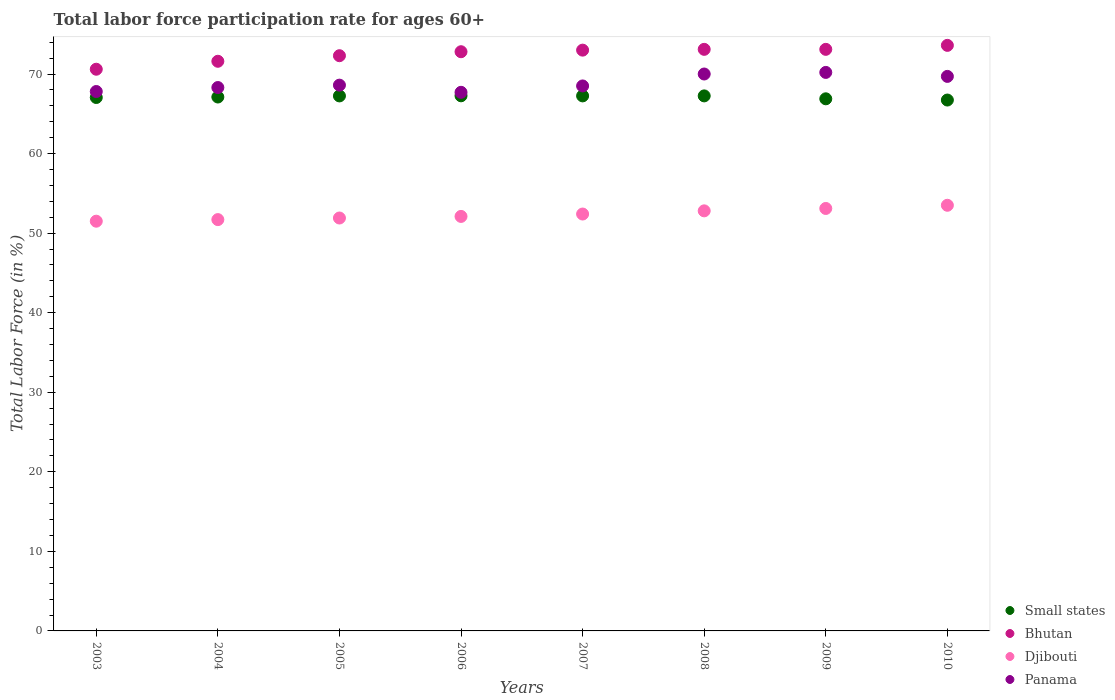Is the number of dotlines equal to the number of legend labels?
Offer a terse response. Yes. What is the labor force participation rate in Djibouti in 2008?
Your answer should be compact. 52.8. Across all years, what is the maximum labor force participation rate in Bhutan?
Offer a very short reply. 73.6. Across all years, what is the minimum labor force participation rate in Djibouti?
Make the answer very short. 51.5. What is the total labor force participation rate in Panama in the graph?
Your answer should be very brief. 550.8. What is the difference between the labor force participation rate in Djibouti in 2004 and that in 2010?
Your response must be concise. -1.8. What is the difference between the labor force participation rate in Djibouti in 2004 and the labor force participation rate in Panama in 2009?
Your answer should be compact. -18.5. What is the average labor force participation rate in Panama per year?
Give a very brief answer. 68.85. In the year 2008, what is the difference between the labor force participation rate in Panama and labor force participation rate in Djibouti?
Your answer should be compact. 17.2. What is the ratio of the labor force participation rate in Djibouti in 2009 to that in 2010?
Your answer should be compact. 0.99. Is the difference between the labor force participation rate in Panama in 2006 and 2007 greater than the difference between the labor force participation rate in Djibouti in 2006 and 2007?
Give a very brief answer. No. What is the difference between the highest and the second highest labor force participation rate in Djibouti?
Your response must be concise. 0.4. What is the difference between the highest and the lowest labor force participation rate in Bhutan?
Your answer should be compact. 3. Is it the case that in every year, the sum of the labor force participation rate in Bhutan and labor force participation rate in Panama  is greater than the labor force participation rate in Djibouti?
Offer a terse response. Yes. Is the labor force participation rate in Djibouti strictly less than the labor force participation rate in Bhutan over the years?
Your answer should be compact. Yes. How many dotlines are there?
Your answer should be very brief. 4. How many years are there in the graph?
Your answer should be compact. 8. Are the values on the major ticks of Y-axis written in scientific E-notation?
Ensure brevity in your answer.  No. Does the graph contain any zero values?
Your answer should be very brief. No. How many legend labels are there?
Provide a succinct answer. 4. How are the legend labels stacked?
Provide a succinct answer. Vertical. What is the title of the graph?
Provide a short and direct response. Total labor force participation rate for ages 60+. Does "Cuba" appear as one of the legend labels in the graph?
Provide a succinct answer. No. What is the Total Labor Force (in %) of Small states in 2003?
Make the answer very short. 67.05. What is the Total Labor Force (in %) in Bhutan in 2003?
Give a very brief answer. 70.6. What is the Total Labor Force (in %) in Djibouti in 2003?
Provide a succinct answer. 51.5. What is the Total Labor Force (in %) in Panama in 2003?
Keep it short and to the point. 67.8. What is the Total Labor Force (in %) of Small states in 2004?
Ensure brevity in your answer.  67.11. What is the Total Labor Force (in %) in Bhutan in 2004?
Give a very brief answer. 71.6. What is the Total Labor Force (in %) of Djibouti in 2004?
Your answer should be very brief. 51.7. What is the Total Labor Force (in %) of Panama in 2004?
Offer a very short reply. 68.3. What is the Total Labor Force (in %) in Small states in 2005?
Provide a short and direct response. 67.25. What is the Total Labor Force (in %) of Bhutan in 2005?
Give a very brief answer. 72.3. What is the Total Labor Force (in %) of Djibouti in 2005?
Offer a terse response. 51.9. What is the Total Labor Force (in %) in Panama in 2005?
Offer a very short reply. 68.6. What is the Total Labor Force (in %) of Small states in 2006?
Your response must be concise. 67.26. What is the Total Labor Force (in %) of Bhutan in 2006?
Offer a terse response. 72.8. What is the Total Labor Force (in %) of Djibouti in 2006?
Your answer should be compact. 52.1. What is the Total Labor Force (in %) in Panama in 2006?
Keep it short and to the point. 67.7. What is the Total Labor Force (in %) in Small states in 2007?
Provide a succinct answer. 67.25. What is the Total Labor Force (in %) in Bhutan in 2007?
Ensure brevity in your answer.  73. What is the Total Labor Force (in %) in Djibouti in 2007?
Ensure brevity in your answer.  52.4. What is the Total Labor Force (in %) of Panama in 2007?
Offer a terse response. 68.5. What is the Total Labor Force (in %) of Small states in 2008?
Offer a very short reply. 67.25. What is the Total Labor Force (in %) of Bhutan in 2008?
Ensure brevity in your answer.  73.1. What is the Total Labor Force (in %) in Djibouti in 2008?
Ensure brevity in your answer.  52.8. What is the Total Labor Force (in %) in Small states in 2009?
Offer a terse response. 66.88. What is the Total Labor Force (in %) of Bhutan in 2009?
Make the answer very short. 73.1. What is the Total Labor Force (in %) in Djibouti in 2009?
Keep it short and to the point. 53.1. What is the Total Labor Force (in %) of Panama in 2009?
Your response must be concise. 70.2. What is the Total Labor Force (in %) of Small states in 2010?
Your response must be concise. 66.73. What is the Total Labor Force (in %) in Bhutan in 2010?
Your answer should be very brief. 73.6. What is the Total Labor Force (in %) in Djibouti in 2010?
Your response must be concise. 53.5. What is the Total Labor Force (in %) of Panama in 2010?
Offer a very short reply. 69.7. Across all years, what is the maximum Total Labor Force (in %) of Small states?
Give a very brief answer. 67.26. Across all years, what is the maximum Total Labor Force (in %) in Bhutan?
Make the answer very short. 73.6. Across all years, what is the maximum Total Labor Force (in %) in Djibouti?
Make the answer very short. 53.5. Across all years, what is the maximum Total Labor Force (in %) of Panama?
Give a very brief answer. 70.2. Across all years, what is the minimum Total Labor Force (in %) in Small states?
Offer a terse response. 66.73. Across all years, what is the minimum Total Labor Force (in %) in Bhutan?
Provide a short and direct response. 70.6. Across all years, what is the minimum Total Labor Force (in %) in Djibouti?
Provide a short and direct response. 51.5. Across all years, what is the minimum Total Labor Force (in %) of Panama?
Make the answer very short. 67.7. What is the total Total Labor Force (in %) of Small states in the graph?
Offer a very short reply. 536.77. What is the total Total Labor Force (in %) of Bhutan in the graph?
Provide a short and direct response. 580.1. What is the total Total Labor Force (in %) in Djibouti in the graph?
Give a very brief answer. 419. What is the total Total Labor Force (in %) in Panama in the graph?
Your answer should be very brief. 550.8. What is the difference between the Total Labor Force (in %) in Small states in 2003 and that in 2004?
Offer a very short reply. -0.06. What is the difference between the Total Labor Force (in %) of Djibouti in 2003 and that in 2004?
Your answer should be very brief. -0.2. What is the difference between the Total Labor Force (in %) in Panama in 2003 and that in 2004?
Ensure brevity in your answer.  -0.5. What is the difference between the Total Labor Force (in %) in Small states in 2003 and that in 2005?
Keep it short and to the point. -0.2. What is the difference between the Total Labor Force (in %) in Panama in 2003 and that in 2005?
Your answer should be very brief. -0.8. What is the difference between the Total Labor Force (in %) in Small states in 2003 and that in 2006?
Keep it short and to the point. -0.21. What is the difference between the Total Labor Force (in %) of Bhutan in 2003 and that in 2006?
Provide a succinct answer. -2.2. What is the difference between the Total Labor Force (in %) of Panama in 2003 and that in 2006?
Provide a short and direct response. 0.1. What is the difference between the Total Labor Force (in %) of Small states in 2003 and that in 2007?
Provide a short and direct response. -0.2. What is the difference between the Total Labor Force (in %) of Bhutan in 2003 and that in 2007?
Provide a succinct answer. -2.4. What is the difference between the Total Labor Force (in %) in Panama in 2003 and that in 2007?
Your response must be concise. -0.7. What is the difference between the Total Labor Force (in %) in Small states in 2003 and that in 2008?
Make the answer very short. -0.2. What is the difference between the Total Labor Force (in %) in Bhutan in 2003 and that in 2008?
Provide a short and direct response. -2.5. What is the difference between the Total Labor Force (in %) in Djibouti in 2003 and that in 2008?
Provide a short and direct response. -1.3. What is the difference between the Total Labor Force (in %) in Panama in 2003 and that in 2008?
Your answer should be compact. -2.2. What is the difference between the Total Labor Force (in %) in Small states in 2003 and that in 2009?
Your answer should be very brief. 0.17. What is the difference between the Total Labor Force (in %) of Bhutan in 2003 and that in 2009?
Your answer should be compact. -2.5. What is the difference between the Total Labor Force (in %) of Djibouti in 2003 and that in 2009?
Offer a very short reply. -1.6. What is the difference between the Total Labor Force (in %) of Small states in 2003 and that in 2010?
Provide a short and direct response. 0.32. What is the difference between the Total Labor Force (in %) of Small states in 2004 and that in 2005?
Make the answer very short. -0.14. What is the difference between the Total Labor Force (in %) in Bhutan in 2004 and that in 2005?
Provide a succinct answer. -0.7. What is the difference between the Total Labor Force (in %) in Small states in 2004 and that in 2006?
Provide a short and direct response. -0.15. What is the difference between the Total Labor Force (in %) in Djibouti in 2004 and that in 2006?
Your response must be concise. -0.4. What is the difference between the Total Labor Force (in %) in Small states in 2004 and that in 2007?
Your answer should be compact. -0.14. What is the difference between the Total Labor Force (in %) of Bhutan in 2004 and that in 2007?
Make the answer very short. -1.4. What is the difference between the Total Labor Force (in %) of Panama in 2004 and that in 2007?
Keep it short and to the point. -0.2. What is the difference between the Total Labor Force (in %) in Small states in 2004 and that in 2008?
Offer a terse response. -0.14. What is the difference between the Total Labor Force (in %) of Bhutan in 2004 and that in 2008?
Ensure brevity in your answer.  -1.5. What is the difference between the Total Labor Force (in %) in Panama in 2004 and that in 2008?
Offer a terse response. -1.7. What is the difference between the Total Labor Force (in %) in Small states in 2004 and that in 2009?
Ensure brevity in your answer.  0.22. What is the difference between the Total Labor Force (in %) of Small states in 2004 and that in 2010?
Keep it short and to the point. 0.38. What is the difference between the Total Labor Force (in %) of Small states in 2005 and that in 2006?
Offer a very short reply. -0.01. What is the difference between the Total Labor Force (in %) of Djibouti in 2005 and that in 2006?
Your answer should be compact. -0.2. What is the difference between the Total Labor Force (in %) of Panama in 2005 and that in 2006?
Make the answer very short. 0.9. What is the difference between the Total Labor Force (in %) in Small states in 2005 and that in 2007?
Provide a succinct answer. -0. What is the difference between the Total Labor Force (in %) of Bhutan in 2005 and that in 2007?
Your response must be concise. -0.7. What is the difference between the Total Labor Force (in %) of Panama in 2005 and that in 2007?
Your answer should be compact. 0.1. What is the difference between the Total Labor Force (in %) in Small states in 2005 and that in 2008?
Offer a terse response. -0. What is the difference between the Total Labor Force (in %) in Djibouti in 2005 and that in 2008?
Your answer should be very brief. -0.9. What is the difference between the Total Labor Force (in %) of Panama in 2005 and that in 2008?
Offer a very short reply. -1.4. What is the difference between the Total Labor Force (in %) in Small states in 2005 and that in 2009?
Provide a succinct answer. 0.36. What is the difference between the Total Labor Force (in %) of Djibouti in 2005 and that in 2009?
Make the answer very short. -1.2. What is the difference between the Total Labor Force (in %) in Panama in 2005 and that in 2009?
Ensure brevity in your answer.  -1.6. What is the difference between the Total Labor Force (in %) in Small states in 2005 and that in 2010?
Your answer should be very brief. 0.52. What is the difference between the Total Labor Force (in %) in Bhutan in 2005 and that in 2010?
Your answer should be compact. -1.3. What is the difference between the Total Labor Force (in %) in Djibouti in 2005 and that in 2010?
Your response must be concise. -1.6. What is the difference between the Total Labor Force (in %) of Panama in 2005 and that in 2010?
Provide a short and direct response. -1.1. What is the difference between the Total Labor Force (in %) of Small states in 2006 and that in 2007?
Offer a terse response. 0.01. What is the difference between the Total Labor Force (in %) in Bhutan in 2006 and that in 2007?
Your response must be concise. -0.2. What is the difference between the Total Labor Force (in %) of Djibouti in 2006 and that in 2007?
Your answer should be very brief. -0.3. What is the difference between the Total Labor Force (in %) in Small states in 2006 and that in 2008?
Offer a terse response. 0.01. What is the difference between the Total Labor Force (in %) in Bhutan in 2006 and that in 2008?
Ensure brevity in your answer.  -0.3. What is the difference between the Total Labor Force (in %) of Djibouti in 2006 and that in 2008?
Provide a short and direct response. -0.7. What is the difference between the Total Labor Force (in %) of Panama in 2006 and that in 2008?
Ensure brevity in your answer.  -2.3. What is the difference between the Total Labor Force (in %) in Small states in 2006 and that in 2009?
Your response must be concise. 0.38. What is the difference between the Total Labor Force (in %) in Bhutan in 2006 and that in 2009?
Provide a short and direct response. -0.3. What is the difference between the Total Labor Force (in %) of Djibouti in 2006 and that in 2009?
Your answer should be very brief. -1. What is the difference between the Total Labor Force (in %) of Panama in 2006 and that in 2009?
Your response must be concise. -2.5. What is the difference between the Total Labor Force (in %) of Small states in 2006 and that in 2010?
Ensure brevity in your answer.  0.53. What is the difference between the Total Labor Force (in %) of Djibouti in 2006 and that in 2010?
Make the answer very short. -1.4. What is the difference between the Total Labor Force (in %) of Panama in 2006 and that in 2010?
Provide a short and direct response. -2. What is the difference between the Total Labor Force (in %) in Bhutan in 2007 and that in 2008?
Keep it short and to the point. -0.1. What is the difference between the Total Labor Force (in %) of Djibouti in 2007 and that in 2008?
Your response must be concise. -0.4. What is the difference between the Total Labor Force (in %) of Panama in 2007 and that in 2008?
Offer a very short reply. -1.5. What is the difference between the Total Labor Force (in %) of Small states in 2007 and that in 2009?
Offer a terse response. 0.37. What is the difference between the Total Labor Force (in %) in Bhutan in 2007 and that in 2009?
Your answer should be very brief. -0.1. What is the difference between the Total Labor Force (in %) in Djibouti in 2007 and that in 2009?
Your answer should be very brief. -0.7. What is the difference between the Total Labor Force (in %) of Small states in 2007 and that in 2010?
Your answer should be very brief. 0.52. What is the difference between the Total Labor Force (in %) of Bhutan in 2007 and that in 2010?
Your response must be concise. -0.6. What is the difference between the Total Labor Force (in %) in Small states in 2008 and that in 2009?
Provide a short and direct response. 0.37. What is the difference between the Total Labor Force (in %) in Small states in 2008 and that in 2010?
Keep it short and to the point. 0.52. What is the difference between the Total Labor Force (in %) in Bhutan in 2008 and that in 2010?
Offer a terse response. -0.5. What is the difference between the Total Labor Force (in %) in Djibouti in 2008 and that in 2010?
Keep it short and to the point. -0.7. What is the difference between the Total Labor Force (in %) of Small states in 2009 and that in 2010?
Offer a terse response. 0.15. What is the difference between the Total Labor Force (in %) in Djibouti in 2009 and that in 2010?
Provide a short and direct response. -0.4. What is the difference between the Total Labor Force (in %) of Small states in 2003 and the Total Labor Force (in %) of Bhutan in 2004?
Keep it short and to the point. -4.55. What is the difference between the Total Labor Force (in %) of Small states in 2003 and the Total Labor Force (in %) of Djibouti in 2004?
Provide a short and direct response. 15.35. What is the difference between the Total Labor Force (in %) in Small states in 2003 and the Total Labor Force (in %) in Panama in 2004?
Offer a very short reply. -1.25. What is the difference between the Total Labor Force (in %) in Bhutan in 2003 and the Total Labor Force (in %) in Panama in 2004?
Give a very brief answer. 2.3. What is the difference between the Total Labor Force (in %) of Djibouti in 2003 and the Total Labor Force (in %) of Panama in 2004?
Your answer should be compact. -16.8. What is the difference between the Total Labor Force (in %) of Small states in 2003 and the Total Labor Force (in %) of Bhutan in 2005?
Offer a very short reply. -5.25. What is the difference between the Total Labor Force (in %) in Small states in 2003 and the Total Labor Force (in %) in Djibouti in 2005?
Provide a short and direct response. 15.15. What is the difference between the Total Labor Force (in %) in Small states in 2003 and the Total Labor Force (in %) in Panama in 2005?
Give a very brief answer. -1.55. What is the difference between the Total Labor Force (in %) in Bhutan in 2003 and the Total Labor Force (in %) in Djibouti in 2005?
Provide a short and direct response. 18.7. What is the difference between the Total Labor Force (in %) in Djibouti in 2003 and the Total Labor Force (in %) in Panama in 2005?
Make the answer very short. -17.1. What is the difference between the Total Labor Force (in %) in Small states in 2003 and the Total Labor Force (in %) in Bhutan in 2006?
Provide a succinct answer. -5.75. What is the difference between the Total Labor Force (in %) of Small states in 2003 and the Total Labor Force (in %) of Djibouti in 2006?
Keep it short and to the point. 14.95. What is the difference between the Total Labor Force (in %) in Small states in 2003 and the Total Labor Force (in %) in Panama in 2006?
Provide a succinct answer. -0.65. What is the difference between the Total Labor Force (in %) in Djibouti in 2003 and the Total Labor Force (in %) in Panama in 2006?
Your answer should be very brief. -16.2. What is the difference between the Total Labor Force (in %) in Small states in 2003 and the Total Labor Force (in %) in Bhutan in 2007?
Offer a terse response. -5.95. What is the difference between the Total Labor Force (in %) in Small states in 2003 and the Total Labor Force (in %) in Djibouti in 2007?
Offer a very short reply. 14.65. What is the difference between the Total Labor Force (in %) in Small states in 2003 and the Total Labor Force (in %) in Panama in 2007?
Your answer should be very brief. -1.45. What is the difference between the Total Labor Force (in %) of Bhutan in 2003 and the Total Labor Force (in %) of Djibouti in 2007?
Offer a terse response. 18.2. What is the difference between the Total Labor Force (in %) of Small states in 2003 and the Total Labor Force (in %) of Bhutan in 2008?
Keep it short and to the point. -6.05. What is the difference between the Total Labor Force (in %) of Small states in 2003 and the Total Labor Force (in %) of Djibouti in 2008?
Give a very brief answer. 14.25. What is the difference between the Total Labor Force (in %) in Small states in 2003 and the Total Labor Force (in %) in Panama in 2008?
Provide a short and direct response. -2.95. What is the difference between the Total Labor Force (in %) in Bhutan in 2003 and the Total Labor Force (in %) in Djibouti in 2008?
Provide a short and direct response. 17.8. What is the difference between the Total Labor Force (in %) in Bhutan in 2003 and the Total Labor Force (in %) in Panama in 2008?
Provide a short and direct response. 0.6. What is the difference between the Total Labor Force (in %) of Djibouti in 2003 and the Total Labor Force (in %) of Panama in 2008?
Your answer should be compact. -18.5. What is the difference between the Total Labor Force (in %) of Small states in 2003 and the Total Labor Force (in %) of Bhutan in 2009?
Your answer should be very brief. -6.05. What is the difference between the Total Labor Force (in %) of Small states in 2003 and the Total Labor Force (in %) of Djibouti in 2009?
Offer a very short reply. 13.95. What is the difference between the Total Labor Force (in %) in Small states in 2003 and the Total Labor Force (in %) in Panama in 2009?
Your answer should be very brief. -3.15. What is the difference between the Total Labor Force (in %) in Bhutan in 2003 and the Total Labor Force (in %) in Djibouti in 2009?
Provide a succinct answer. 17.5. What is the difference between the Total Labor Force (in %) in Djibouti in 2003 and the Total Labor Force (in %) in Panama in 2009?
Keep it short and to the point. -18.7. What is the difference between the Total Labor Force (in %) in Small states in 2003 and the Total Labor Force (in %) in Bhutan in 2010?
Offer a very short reply. -6.55. What is the difference between the Total Labor Force (in %) in Small states in 2003 and the Total Labor Force (in %) in Djibouti in 2010?
Keep it short and to the point. 13.55. What is the difference between the Total Labor Force (in %) in Small states in 2003 and the Total Labor Force (in %) in Panama in 2010?
Make the answer very short. -2.65. What is the difference between the Total Labor Force (in %) of Bhutan in 2003 and the Total Labor Force (in %) of Djibouti in 2010?
Provide a succinct answer. 17.1. What is the difference between the Total Labor Force (in %) in Bhutan in 2003 and the Total Labor Force (in %) in Panama in 2010?
Give a very brief answer. 0.9. What is the difference between the Total Labor Force (in %) in Djibouti in 2003 and the Total Labor Force (in %) in Panama in 2010?
Make the answer very short. -18.2. What is the difference between the Total Labor Force (in %) of Small states in 2004 and the Total Labor Force (in %) of Bhutan in 2005?
Provide a succinct answer. -5.19. What is the difference between the Total Labor Force (in %) of Small states in 2004 and the Total Labor Force (in %) of Djibouti in 2005?
Provide a short and direct response. 15.21. What is the difference between the Total Labor Force (in %) in Small states in 2004 and the Total Labor Force (in %) in Panama in 2005?
Offer a very short reply. -1.49. What is the difference between the Total Labor Force (in %) in Djibouti in 2004 and the Total Labor Force (in %) in Panama in 2005?
Your response must be concise. -16.9. What is the difference between the Total Labor Force (in %) in Small states in 2004 and the Total Labor Force (in %) in Bhutan in 2006?
Keep it short and to the point. -5.69. What is the difference between the Total Labor Force (in %) of Small states in 2004 and the Total Labor Force (in %) of Djibouti in 2006?
Provide a succinct answer. 15.01. What is the difference between the Total Labor Force (in %) of Small states in 2004 and the Total Labor Force (in %) of Panama in 2006?
Provide a succinct answer. -0.59. What is the difference between the Total Labor Force (in %) in Bhutan in 2004 and the Total Labor Force (in %) in Djibouti in 2006?
Give a very brief answer. 19.5. What is the difference between the Total Labor Force (in %) in Small states in 2004 and the Total Labor Force (in %) in Bhutan in 2007?
Keep it short and to the point. -5.89. What is the difference between the Total Labor Force (in %) in Small states in 2004 and the Total Labor Force (in %) in Djibouti in 2007?
Ensure brevity in your answer.  14.71. What is the difference between the Total Labor Force (in %) in Small states in 2004 and the Total Labor Force (in %) in Panama in 2007?
Give a very brief answer. -1.39. What is the difference between the Total Labor Force (in %) of Djibouti in 2004 and the Total Labor Force (in %) of Panama in 2007?
Provide a succinct answer. -16.8. What is the difference between the Total Labor Force (in %) of Small states in 2004 and the Total Labor Force (in %) of Bhutan in 2008?
Provide a succinct answer. -5.99. What is the difference between the Total Labor Force (in %) of Small states in 2004 and the Total Labor Force (in %) of Djibouti in 2008?
Provide a succinct answer. 14.31. What is the difference between the Total Labor Force (in %) in Small states in 2004 and the Total Labor Force (in %) in Panama in 2008?
Offer a terse response. -2.89. What is the difference between the Total Labor Force (in %) in Djibouti in 2004 and the Total Labor Force (in %) in Panama in 2008?
Your response must be concise. -18.3. What is the difference between the Total Labor Force (in %) of Small states in 2004 and the Total Labor Force (in %) of Bhutan in 2009?
Offer a terse response. -5.99. What is the difference between the Total Labor Force (in %) of Small states in 2004 and the Total Labor Force (in %) of Djibouti in 2009?
Provide a short and direct response. 14.01. What is the difference between the Total Labor Force (in %) in Small states in 2004 and the Total Labor Force (in %) in Panama in 2009?
Make the answer very short. -3.09. What is the difference between the Total Labor Force (in %) of Djibouti in 2004 and the Total Labor Force (in %) of Panama in 2009?
Give a very brief answer. -18.5. What is the difference between the Total Labor Force (in %) in Small states in 2004 and the Total Labor Force (in %) in Bhutan in 2010?
Ensure brevity in your answer.  -6.49. What is the difference between the Total Labor Force (in %) in Small states in 2004 and the Total Labor Force (in %) in Djibouti in 2010?
Keep it short and to the point. 13.61. What is the difference between the Total Labor Force (in %) of Small states in 2004 and the Total Labor Force (in %) of Panama in 2010?
Offer a terse response. -2.59. What is the difference between the Total Labor Force (in %) in Bhutan in 2004 and the Total Labor Force (in %) in Djibouti in 2010?
Keep it short and to the point. 18.1. What is the difference between the Total Labor Force (in %) in Bhutan in 2004 and the Total Labor Force (in %) in Panama in 2010?
Provide a short and direct response. 1.9. What is the difference between the Total Labor Force (in %) in Small states in 2005 and the Total Labor Force (in %) in Bhutan in 2006?
Provide a succinct answer. -5.55. What is the difference between the Total Labor Force (in %) of Small states in 2005 and the Total Labor Force (in %) of Djibouti in 2006?
Make the answer very short. 15.15. What is the difference between the Total Labor Force (in %) of Small states in 2005 and the Total Labor Force (in %) of Panama in 2006?
Your answer should be compact. -0.45. What is the difference between the Total Labor Force (in %) of Bhutan in 2005 and the Total Labor Force (in %) of Djibouti in 2006?
Provide a succinct answer. 20.2. What is the difference between the Total Labor Force (in %) of Djibouti in 2005 and the Total Labor Force (in %) of Panama in 2006?
Offer a terse response. -15.8. What is the difference between the Total Labor Force (in %) in Small states in 2005 and the Total Labor Force (in %) in Bhutan in 2007?
Make the answer very short. -5.75. What is the difference between the Total Labor Force (in %) of Small states in 2005 and the Total Labor Force (in %) of Djibouti in 2007?
Ensure brevity in your answer.  14.85. What is the difference between the Total Labor Force (in %) of Small states in 2005 and the Total Labor Force (in %) of Panama in 2007?
Provide a succinct answer. -1.25. What is the difference between the Total Labor Force (in %) in Bhutan in 2005 and the Total Labor Force (in %) in Djibouti in 2007?
Your answer should be compact. 19.9. What is the difference between the Total Labor Force (in %) in Bhutan in 2005 and the Total Labor Force (in %) in Panama in 2007?
Offer a very short reply. 3.8. What is the difference between the Total Labor Force (in %) in Djibouti in 2005 and the Total Labor Force (in %) in Panama in 2007?
Make the answer very short. -16.6. What is the difference between the Total Labor Force (in %) in Small states in 2005 and the Total Labor Force (in %) in Bhutan in 2008?
Your response must be concise. -5.85. What is the difference between the Total Labor Force (in %) of Small states in 2005 and the Total Labor Force (in %) of Djibouti in 2008?
Offer a terse response. 14.45. What is the difference between the Total Labor Force (in %) of Small states in 2005 and the Total Labor Force (in %) of Panama in 2008?
Ensure brevity in your answer.  -2.75. What is the difference between the Total Labor Force (in %) of Djibouti in 2005 and the Total Labor Force (in %) of Panama in 2008?
Ensure brevity in your answer.  -18.1. What is the difference between the Total Labor Force (in %) of Small states in 2005 and the Total Labor Force (in %) of Bhutan in 2009?
Keep it short and to the point. -5.85. What is the difference between the Total Labor Force (in %) of Small states in 2005 and the Total Labor Force (in %) of Djibouti in 2009?
Your answer should be compact. 14.15. What is the difference between the Total Labor Force (in %) of Small states in 2005 and the Total Labor Force (in %) of Panama in 2009?
Keep it short and to the point. -2.95. What is the difference between the Total Labor Force (in %) in Bhutan in 2005 and the Total Labor Force (in %) in Djibouti in 2009?
Offer a terse response. 19.2. What is the difference between the Total Labor Force (in %) in Bhutan in 2005 and the Total Labor Force (in %) in Panama in 2009?
Make the answer very short. 2.1. What is the difference between the Total Labor Force (in %) in Djibouti in 2005 and the Total Labor Force (in %) in Panama in 2009?
Offer a terse response. -18.3. What is the difference between the Total Labor Force (in %) in Small states in 2005 and the Total Labor Force (in %) in Bhutan in 2010?
Ensure brevity in your answer.  -6.35. What is the difference between the Total Labor Force (in %) of Small states in 2005 and the Total Labor Force (in %) of Djibouti in 2010?
Your answer should be compact. 13.75. What is the difference between the Total Labor Force (in %) in Small states in 2005 and the Total Labor Force (in %) in Panama in 2010?
Provide a short and direct response. -2.45. What is the difference between the Total Labor Force (in %) of Bhutan in 2005 and the Total Labor Force (in %) of Djibouti in 2010?
Give a very brief answer. 18.8. What is the difference between the Total Labor Force (in %) of Djibouti in 2005 and the Total Labor Force (in %) of Panama in 2010?
Keep it short and to the point. -17.8. What is the difference between the Total Labor Force (in %) of Small states in 2006 and the Total Labor Force (in %) of Bhutan in 2007?
Your answer should be very brief. -5.74. What is the difference between the Total Labor Force (in %) of Small states in 2006 and the Total Labor Force (in %) of Djibouti in 2007?
Give a very brief answer. 14.86. What is the difference between the Total Labor Force (in %) in Small states in 2006 and the Total Labor Force (in %) in Panama in 2007?
Ensure brevity in your answer.  -1.24. What is the difference between the Total Labor Force (in %) in Bhutan in 2006 and the Total Labor Force (in %) in Djibouti in 2007?
Ensure brevity in your answer.  20.4. What is the difference between the Total Labor Force (in %) in Djibouti in 2006 and the Total Labor Force (in %) in Panama in 2007?
Offer a very short reply. -16.4. What is the difference between the Total Labor Force (in %) of Small states in 2006 and the Total Labor Force (in %) of Bhutan in 2008?
Give a very brief answer. -5.84. What is the difference between the Total Labor Force (in %) in Small states in 2006 and the Total Labor Force (in %) in Djibouti in 2008?
Make the answer very short. 14.46. What is the difference between the Total Labor Force (in %) of Small states in 2006 and the Total Labor Force (in %) of Panama in 2008?
Keep it short and to the point. -2.74. What is the difference between the Total Labor Force (in %) in Bhutan in 2006 and the Total Labor Force (in %) in Panama in 2008?
Provide a succinct answer. 2.8. What is the difference between the Total Labor Force (in %) of Djibouti in 2006 and the Total Labor Force (in %) of Panama in 2008?
Your answer should be compact. -17.9. What is the difference between the Total Labor Force (in %) of Small states in 2006 and the Total Labor Force (in %) of Bhutan in 2009?
Provide a succinct answer. -5.84. What is the difference between the Total Labor Force (in %) in Small states in 2006 and the Total Labor Force (in %) in Djibouti in 2009?
Offer a very short reply. 14.16. What is the difference between the Total Labor Force (in %) in Small states in 2006 and the Total Labor Force (in %) in Panama in 2009?
Offer a very short reply. -2.94. What is the difference between the Total Labor Force (in %) of Bhutan in 2006 and the Total Labor Force (in %) of Djibouti in 2009?
Provide a short and direct response. 19.7. What is the difference between the Total Labor Force (in %) of Djibouti in 2006 and the Total Labor Force (in %) of Panama in 2009?
Provide a succinct answer. -18.1. What is the difference between the Total Labor Force (in %) of Small states in 2006 and the Total Labor Force (in %) of Bhutan in 2010?
Give a very brief answer. -6.34. What is the difference between the Total Labor Force (in %) in Small states in 2006 and the Total Labor Force (in %) in Djibouti in 2010?
Your answer should be compact. 13.76. What is the difference between the Total Labor Force (in %) of Small states in 2006 and the Total Labor Force (in %) of Panama in 2010?
Offer a terse response. -2.44. What is the difference between the Total Labor Force (in %) in Bhutan in 2006 and the Total Labor Force (in %) in Djibouti in 2010?
Your answer should be compact. 19.3. What is the difference between the Total Labor Force (in %) of Bhutan in 2006 and the Total Labor Force (in %) of Panama in 2010?
Provide a short and direct response. 3.1. What is the difference between the Total Labor Force (in %) of Djibouti in 2006 and the Total Labor Force (in %) of Panama in 2010?
Your answer should be very brief. -17.6. What is the difference between the Total Labor Force (in %) of Small states in 2007 and the Total Labor Force (in %) of Bhutan in 2008?
Keep it short and to the point. -5.85. What is the difference between the Total Labor Force (in %) in Small states in 2007 and the Total Labor Force (in %) in Djibouti in 2008?
Offer a very short reply. 14.45. What is the difference between the Total Labor Force (in %) in Small states in 2007 and the Total Labor Force (in %) in Panama in 2008?
Make the answer very short. -2.75. What is the difference between the Total Labor Force (in %) of Bhutan in 2007 and the Total Labor Force (in %) of Djibouti in 2008?
Your response must be concise. 20.2. What is the difference between the Total Labor Force (in %) in Bhutan in 2007 and the Total Labor Force (in %) in Panama in 2008?
Your answer should be very brief. 3. What is the difference between the Total Labor Force (in %) in Djibouti in 2007 and the Total Labor Force (in %) in Panama in 2008?
Provide a short and direct response. -17.6. What is the difference between the Total Labor Force (in %) of Small states in 2007 and the Total Labor Force (in %) of Bhutan in 2009?
Offer a very short reply. -5.85. What is the difference between the Total Labor Force (in %) in Small states in 2007 and the Total Labor Force (in %) in Djibouti in 2009?
Offer a very short reply. 14.15. What is the difference between the Total Labor Force (in %) of Small states in 2007 and the Total Labor Force (in %) of Panama in 2009?
Ensure brevity in your answer.  -2.95. What is the difference between the Total Labor Force (in %) in Bhutan in 2007 and the Total Labor Force (in %) in Panama in 2009?
Offer a terse response. 2.8. What is the difference between the Total Labor Force (in %) in Djibouti in 2007 and the Total Labor Force (in %) in Panama in 2009?
Give a very brief answer. -17.8. What is the difference between the Total Labor Force (in %) in Small states in 2007 and the Total Labor Force (in %) in Bhutan in 2010?
Provide a short and direct response. -6.35. What is the difference between the Total Labor Force (in %) in Small states in 2007 and the Total Labor Force (in %) in Djibouti in 2010?
Provide a short and direct response. 13.75. What is the difference between the Total Labor Force (in %) in Small states in 2007 and the Total Labor Force (in %) in Panama in 2010?
Your answer should be very brief. -2.45. What is the difference between the Total Labor Force (in %) of Bhutan in 2007 and the Total Labor Force (in %) of Djibouti in 2010?
Your answer should be very brief. 19.5. What is the difference between the Total Labor Force (in %) of Bhutan in 2007 and the Total Labor Force (in %) of Panama in 2010?
Give a very brief answer. 3.3. What is the difference between the Total Labor Force (in %) in Djibouti in 2007 and the Total Labor Force (in %) in Panama in 2010?
Provide a short and direct response. -17.3. What is the difference between the Total Labor Force (in %) of Small states in 2008 and the Total Labor Force (in %) of Bhutan in 2009?
Your answer should be very brief. -5.85. What is the difference between the Total Labor Force (in %) of Small states in 2008 and the Total Labor Force (in %) of Djibouti in 2009?
Offer a terse response. 14.15. What is the difference between the Total Labor Force (in %) in Small states in 2008 and the Total Labor Force (in %) in Panama in 2009?
Give a very brief answer. -2.95. What is the difference between the Total Labor Force (in %) in Bhutan in 2008 and the Total Labor Force (in %) in Djibouti in 2009?
Provide a succinct answer. 20. What is the difference between the Total Labor Force (in %) of Djibouti in 2008 and the Total Labor Force (in %) of Panama in 2009?
Your answer should be very brief. -17.4. What is the difference between the Total Labor Force (in %) in Small states in 2008 and the Total Labor Force (in %) in Bhutan in 2010?
Make the answer very short. -6.35. What is the difference between the Total Labor Force (in %) in Small states in 2008 and the Total Labor Force (in %) in Djibouti in 2010?
Ensure brevity in your answer.  13.75. What is the difference between the Total Labor Force (in %) of Small states in 2008 and the Total Labor Force (in %) of Panama in 2010?
Offer a terse response. -2.45. What is the difference between the Total Labor Force (in %) of Bhutan in 2008 and the Total Labor Force (in %) of Djibouti in 2010?
Give a very brief answer. 19.6. What is the difference between the Total Labor Force (in %) of Bhutan in 2008 and the Total Labor Force (in %) of Panama in 2010?
Offer a terse response. 3.4. What is the difference between the Total Labor Force (in %) of Djibouti in 2008 and the Total Labor Force (in %) of Panama in 2010?
Offer a very short reply. -16.9. What is the difference between the Total Labor Force (in %) of Small states in 2009 and the Total Labor Force (in %) of Bhutan in 2010?
Offer a terse response. -6.72. What is the difference between the Total Labor Force (in %) in Small states in 2009 and the Total Labor Force (in %) in Djibouti in 2010?
Your answer should be very brief. 13.38. What is the difference between the Total Labor Force (in %) in Small states in 2009 and the Total Labor Force (in %) in Panama in 2010?
Give a very brief answer. -2.82. What is the difference between the Total Labor Force (in %) in Bhutan in 2009 and the Total Labor Force (in %) in Djibouti in 2010?
Keep it short and to the point. 19.6. What is the difference between the Total Labor Force (in %) of Bhutan in 2009 and the Total Labor Force (in %) of Panama in 2010?
Provide a succinct answer. 3.4. What is the difference between the Total Labor Force (in %) in Djibouti in 2009 and the Total Labor Force (in %) in Panama in 2010?
Give a very brief answer. -16.6. What is the average Total Labor Force (in %) of Small states per year?
Keep it short and to the point. 67.1. What is the average Total Labor Force (in %) of Bhutan per year?
Your answer should be very brief. 72.51. What is the average Total Labor Force (in %) of Djibouti per year?
Offer a very short reply. 52.38. What is the average Total Labor Force (in %) in Panama per year?
Give a very brief answer. 68.85. In the year 2003, what is the difference between the Total Labor Force (in %) in Small states and Total Labor Force (in %) in Bhutan?
Make the answer very short. -3.55. In the year 2003, what is the difference between the Total Labor Force (in %) in Small states and Total Labor Force (in %) in Djibouti?
Your answer should be very brief. 15.55. In the year 2003, what is the difference between the Total Labor Force (in %) of Small states and Total Labor Force (in %) of Panama?
Offer a terse response. -0.75. In the year 2003, what is the difference between the Total Labor Force (in %) of Djibouti and Total Labor Force (in %) of Panama?
Your answer should be very brief. -16.3. In the year 2004, what is the difference between the Total Labor Force (in %) of Small states and Total Labor Force (in %) of Bhutan?
Offer a terse response. -4.49. In the year 2004, what is the difference between the Total Labor Force (in %) in Small states and Total Labor Force (in %) in Djibouti?
Your answer should be compact. 15.41. In the year 2004, what is the difference between the Total Labor Force (in %) in Small states and Total Labor Force (in %) in Panama?
Provide a short and direct response. -1.19. In the year 2004, what is the difference between the Total Labor Force (in %) in Bhutan and Total Labor Force (in %) in Djibouti?
Your answer should be compact. 19.9. In the year 2004, what is the difference between the Total Labor Force (in %) in Djibouti and Total Labor Force (in %) in Panama?
Keep it short and to the point. -16.6. In the year 2005, what is the difference between the Total Labor Force (in %) in Small states and Total Labor Force (in %) in Bhutan?
Offer a very short reply. -5.05. In the year 2005, what is the difference between the Total Labor Force (in %) of Small states and Total Labor Force (in %) of Djibouti?
Keep it short and to the point. 15.35. In the year 2005, what is the difference between the Total Labor Force (in %) in Small states and Total Labor Force (in %) in Panama?
Offer a terse response. -1.35. In the year 2005, what is the difference between the Total Labor Force (in %) of Bhutan and Total Labor Force (in %) of Djibouti?
Offer a terse response. 20.4. In the year 2005, what is the difference between the Total Labor Force (in %) in Djibouti and Total Labor Force (in %) in Panama?
Your answer should be compact. -16.7. In the year 2006, what is the difference between the Total Labor Force (in %) in Small states and Total Labor Force (in %) in Bhutan?
Your answer should be compact. -5.54. In the year 2006, what is the difference between the Total Labor Force (in %) in Small states and Total Labor Force (in %) in Djibouti?
Provide a succinct answer. 15.16. In the year 2006, what is the difference between the Total Labor Force (in %) of Small states and Total Labor Force (in %) of Panama?
Your answer should be very brief. -0.44. In the year 2006, what is the difference between the Total Labor Force (in %) of Bhutan and Total Labor Force (in %) of Djibouti?
Provide a short and direct response. 20.7. In the year 2006, what is the difference between the Total Labor Force (in %) in Bhutan and Total Labor Force (in %) in Panama?
Offer a terse response. 5.1. In the year 2006, what is the difference between the Total Labor Force (in %) of Djibouti and Total Labor Force (in %) of Panama?
Provide a succinct answer. -15.6. In the year 2007, what is the difference between the Total Labor Force (in %) of Small states and Total Labor Force (in %) of Bhutan?
Ensure brevity in your answer.  -5.75. In the year 2007, what is the difference between the Total Labor Force (in %) in Small states and Total Labor Force (in %) in Djibouti?
Your response must be concise. 14.85. In the year 2007, what is the difference between the Total Labor Force (in %) of Small states and Total Labor Force (in %) of Panama?
Make the answer very short. -1.25. In the year 2007, what is the difference between the Total Labor Force (in %) in Bhutan and Total Labor Force (in %) in Djibouti?
Provide a succinct answer. 20.6. In the year 2007, what is the difference between the Total Labor Force (in %) of Djibouti and Total Labor Force (in %) of Panama?
Your response must be concise. -16.1. In the year 2008, what is the difference between the Total Labor Force (in %) in Small states and Total Labor Force (in %) in Bhutan?
Keep it short and to the point. -5.85. In the year 2008, what is the difference between the Total Labor Force (in %) of Small states and Total Labor Force (in %) of Djibouti?
Offer a very short reply. 14.45. In the year 2008, what is the difference between the Total Labor Force (in %) in Small states and Total Labor Force (in %) in Panama?
Your answer should be compact. -2.75. In the year 2008, what is the difference between the Total Labor Force (in %) in Bhutan and Total Labor Force (in %) in Djibouti?
Offer a terse response. 20.3. In the year 2008, what is the difference between the Total Labor Force (in %) of Bhutan and Total Labor Force (in %) of Panama?
Ensure brevity in your answer.  3.1. In the year 2008, what is the difference between the Total Labor Force (in %) in Djibouti and Total Labor Force (in %) in Panama?
Your answer should be compact. -17.2. In the year 2009, what is the difference between the Total Labor Force (in %) of Small states and Total Labor Force (in %) of Bhutan?
Provide a short and direct response. -6.22. In the year 2009, what is the difference between the Total Labor Force (in %) in Small states and Total Labor Force (in %) in Djibouti?
Ensure brevity in your answer.  13.78. In the year 2009, what is the difference between the Total Labor Force (in %) in Small states and Total Labor Force (in %) in Panama?
Your answer should be compact. -3.32. In the year 2009, what is the difference between the Total Labor Force (in %) of Bhutan and Total Labor Force (in %) of Panama?
Provide a succinct answer. 2.9. In the year 2009, what is the difference between the Total Labor Force (in %) in Djibouti and Total Labor Force (in %) in Panama?
Offer a very short reply. -17.1. In the year 2010, what is the difference between the Total Labor Force (in %) in Small states and Total Labor Force (in %) in Bhutan?
Offer a very short reply. -6.87. In the year 2010, what is the difference between the Total Labor Force (in %) in Small states and Total Labor Force (in %) in Djibouti?
Give a very brief answer. 13.23. In the year 2010, what is the difference between the Total Labor Force (in %) in Small states and Total Labor Force (in %) in Panama?
Make the answer very short. -2.97. In the year 2010, what is the difference between the Total Labor Force (in %) in Bhutan and Total Labor Force (in %) in Djibouti?
Provide a short and direct response. 20.1. In the year 2010, what is the difference between the Total Labor Force (in %) of Djibouti and Total Labor Force (in %) of Panama?
Make the answer very short. -16.2. What is the ratio of the Total Labor Force (in %) of Djibouti in 2003 to that in 2004?
Your response must be concise. 1. What is the ratio of the Total Labor Force (in %) of Small states in 2003 to that in 2005?
Give a very brief answer. 1. What is the ratio of the Total Labor Force (in %) in Bhutan in 2003 to that in 2005?
Provide a succinct answer. 0.98. What is the ratio of the Total Labor Force (in %) in Djibouti in 2003 to that in 2005?
Your answer should be very brief. 0.99. What is the ratio of the Total Labor Force (in %) in Panama in 2003 to that in 2005?
Make the answer very short. 0.99. What is the ratio of the Total Labor Force (in %) in Bhutan in 2003 to that in 2006?
Provide a succinct answer. 0.97. What is the ratio of the Total Labor Force (in %) in Djibouti in 2003 to that in 2006?
Keep it short and to the point. 0.99. What is the ratio of the Total Labor Force (in %) in Panama in 2003 to that in 2006?
Provide a short and direct response. 1. What is the ratio of the Total Labor Force (in %) of Small states in 2003 to that in 2007?
Provide a succinct answer. 1. What is the ratio of the Total Labor Force (in %) in Bhutan in 2003 to that in 2007?
Offer a very short reply. 0.97. What is the ratio of the Total Labor Force (in %) of Djibouti in 2003 to that in 2007?
Keep it short and to the point. 0.98. What is the ratio of the Total Labor Force (in %) in Panama in 2003 to that in 2007?
Your response must be concise. 0.99. What is the ratio of the Total Labor Force (in %) in Bhutan in 2003 to that in 2008?
Offer a very short reply. 0.97. What is the ratio of the Total Labor Force (in %) in Djibouti in 2003 to that in 2008?
Your answer should be compact. 0.98. What is the ratio of the Total Labor Force (in %) of Panama in 2003 to that in 2008?
Your answer should be compact. 0.97. What is the ratio of the Total Labor Force (in %) of Bhutan in 2003 to that in 2009?
Offer a very short reply. 0.97. What is the ratio of the Total Labor Force (in %) in Djibouti in 2003 to that in 2009?
Your answer should be very brief. 0.97. What is the ratio of the Total Labor Force (in %) in Panama in 2003 to that in 2009?
Your answer should be compact. 0.97. What is the ratio of the Total Labor Force (in %) of Small states in 2003 to that in 2010?
Offer a terse response. 1. What is the ratio of the Total Labor Force (in %) of Bhutan in 2003 to that in 2010?
Provide a succinct answer. 0.96. What is the ratio of the Total Labor Force (in %) in Djibouti in 2003 to that in 2010?
Your answer should be very brief. 0.96. What is the ratio of the Total Labor Force (in %) in Panama in 2003 to that in 2010?
Give a very brief answer. 0.97. What is the ratio of the Total Labor Force (in %) of Small states in 2004 to that in 2005?
Offer a very short reply. 1. What is the ratio of the Total Labor Force (in %) of Bhutan in 2004 to that in 2005?
Ensure brevity in your answer.  0.99. What is the ratio of the Total Labor Force (in %) of Djibouti in 2004 to that in 2005?
Your response must be concise. 1. What is the ratio of the Total Labor Force (in %) of Small states in 2004 to that in 2006?
Provide a succinct answer. 1. What is the ratio of the Total Labor Force (in %) in Bhutan in 2004 to that in 2006?
Your answer should be compact. 0.98. What is the ratio of the Total Labor Force (in %) of Djibouti in 2004 to that in 2006?
Your answer should be very brief. 0.99. What is the ratio of the Total Labor Force (in %) in Panama in 2004 to that in 2006?
Your answer should be very brief. 1.01. What is the ratio of the Total Labor Force (in %) of Bhutan in 2004 to that in 2007?
Your answer should be very brief. 0.98. What is the ratio of the Total Labor Force (in %) of Djibouti in 2004 to that in 2007?
Make the answer very short. 0.99. What is the ratio of the Total Labor Force (in %) of Panama in 2004 to that in 2007?
Your answer should be compact. 1. What is the ratio of the Total Labor Force (in %) in Small states in 2004 to that in 2008?
Provide a short and direct response. 1. What is the ratio of the Total Labor Force (in %) of Bhutan in 2004 to that in 2008?
Your answer should be compact. 0.98. What is the ratio of the Total Labor Force (in %) of Djibouti in 2004 to that in 2008?
Your response must be concise. 0.98. What is the ratio of the Total Labor Force (in %) in Panama in 2004 to that in 2008?
Offer a terse response. 0.98. What is the ratio of the Total Labor Force (in %) in Small states in 2004 to that in 2009?
Give a very brief answer. 1. What is the ratio of the Total Labor Force (in %) of Bhutan in 2004 to that in 2009?
Provide a short and direct response. 0.98. What is the ratio of the Total Labor Force (in %) of Djibouti in 2004 to that in 2009?
Give a very brief answer. 0.97. What is the ratio of the Total Labor Force (in %) of Panama in 2004 to that in 2009?
Ensure brevity in your answer.  0.97. What is the ratio of the Total Labor Force (in %) of Small states in 2004 to that in 2010?
Offer a terse response. 1.01. What is the ratio of the Total Labor Force (in %) in Bhutan in 2004 to that in 2010?
Provide a succinct answer. 0.97. What is the ratio of the Total Labor Force (in %) of Djibouti in 2004 to that in 2010?
Ensure brevity in your answer.  0.97. What is the ratio of the Total Labor Force (in %) of Panama in 2004 to that in 2010?
Ensure brevity in your answer.  0.98. What is the ratio of the Total Labor Force (in %) of Bhutan in 2005 to that in 2006?
Make the answer very short. 0.99. What is the ratio of the Total Labor Force (in %) in Panama in 2005 to that in 2006?
Your answer should be very brief. 1.01. What is the ratio of the Total Labor Force (in %) of Djibouti in 2005 to that in 2007?
Your answer should be compact. 0.99. What is the ratio of the Total Labor Force (in %) in Panama in 2005 to that in 2007?
Offer a terse response. 1. What is the ratio of the Total Labor Force (in %) of Small states in 2005 to that in 2008?
Provide a short and direct response. 1. What is the ratio of the Total Labor Force (in %) in Bhutan in 2005 to that in 2008?
Make the answer very short. 0.99. What is the ratio of the Total Labor Force (in %) of Small states in 2005 to that in 2009?
Ensure brevity in your answer.  1.01. What is the ratio of the Total Labor Force (in %) of Bhutan in 2005 to that in 2009?
Offer a terse response. 0.99. What is the ratio of the Total Labor Force (in %) in Djibouti in 2005 to that in 2009?
Offer a terse response. 0.98. What is the ratio of the Total Labor Force (in %) in Panama in 2005 to that in 2009?
Your answer should be very brief. 0.98. What is the ratio of the Total Labor Force (in %) of Small states in 2005 to that in 2010?
Your answer should be very brief. 1.01. What is the ratio of the Total Labor Force (in %) in Bhutan in 2005 to that in 2010?
Provide a succinct answer. 0.98. What is the ratio of the Total Labor Force (in %) of Djibouti in 2005 to that in 2010?
Provide a succinct answer. 0.97. What is the ratio of the Total Labor Force (in %) in Panama in 2005 to that in 2010?
Offer a very short reply. 0.98. What is the ratio of the Total Labor Force (in %) of Small states in 2006 to that in 2007?
Keep it short and to the point. 1. What is the ratio of the Total Labor Force (in %) in Bhutan in 2006 to that in 2007?
Make the answer very short. 1. What is the ratio of the Total Labor Force (in %) in Djibouti in 2006 to that in 2007?
Your response must be concise. 0.99. What is the ratio of the Total Labor Force (in %) of Panama in 2006 to that in 2007?
Your answer should be very brief. 0.99. What is the ratio of the Total Labor Force (in %) in Bhutan in 2006 to that in 2008?
Your answer should be compact. 1. What is the ratio of the Total Labor Force (in %) in Djibouti in 2006 to that in 2008?
Give a very brief answer. 0.99. What is the ratio of the Total Labor Force (in %) of Panama in 2006 to that in 2008?
Your answer should be very brief. 0.97. What is the ratio of the Total Labor Force (in %) of Small states in 2006 to that in 2009?
Ensure brevity in your answer.  1.01. What is the ratio of the Total Labor Force (in %) of Bhutan in 2006 to that in 2009?
Offer a terse response. 1. What is the ratio of the Total Labor Force (in %) of Djibouti in 2006 to that in 2009?
Provide a short and direct response. 0.98. What is the ratio of the Total Labor Force (in %) of Panama in 2006 to that in 2009?
Ensure brevity in your answer.  0.96. What is the ratio of the Total Labor Force (in %) in Small states in 2006 to that in 2010?
Provide a succinct answer. 1.01. What is the ratio of the Total Labor Force (in %) in Djibouti in 2006 to that in 2010?
Provide a short and direct response. 0.97. What is the ratio of the Total Labor Force (in %) of Panama in 2006 to that in 2010?
Provide a short and direct response. 0.97. What is the ratio of the Total Labor Force (in %) of Small states in 2007 to that in 2008?
Offer a very short reply. 1. What is the ratio of the Total Labor Force (in %) in Panama in 2007 to that in 2008?
Provide a succinct answer. 0.98. What is the ratio of the Total Labor Force (in %) of Small states in 2007 to that in 2009?
Your answer should be very brief. 1.01. What is the ratio of the Total Labor Force (in %) of Bhutan in 2007 to that in 2009?
Keep it short and to the point. 1. What is the ratio of the Total Labor Force (in %) in Djibouti in 2007 to that in 2009?
Your response must be concise. 0.99. What is the ratio of the Total Labor Force (in %) in Panama in 2007 to that in 2009?
Provide a succinct answer. 0.98. What is the ratio of the Total Labor Force (in %) of Small states in 2007 to that in 2010?
Your answer should be compact. 1.01. What is the ratio of the Total Labor Force (in %) of Djibouti in 2007 to that in 2010?
Offer a very short reply. 0.98. What is the ratio of the Total Labor Force (in %) of Panama in 2007 to that in 2010?
Your response must be concise. 0.98. What is the ratio of the Total Labor Force (in %) in Small states in 2008 to that in 2009?
Your response must be concise. 1.01. What is the ratio of the Total Labor Force (in %) of Djibouti in 2008 to that in 2009?
Ensure brevity in your answer.  0.99. What is the ratio of the Total Labor Force (in %) in Panama in 2008 to that in 2009?
Provide a succinct answer. 1. What is the ratio of the Total Labor Force (in %) in Bhutan in 2008 to that in 2010?
Give a very brief answer. 0.99. What is the ratio of the Total Labor Force (in %) of Djibouti in 2008 to that in 2010?
Offer a very short reply. 0.99. What is the ratio of the Total Labor Force (in %) of Panama in 2008 to that in 2010?
Keep it short and to the point. 1. What is the ratio of the Total Labor Force (in %) of Bhutan in 2009 to that in 2010?
Your answer should be compact. 0.99. What is the ratio of the Total Labor Force (in %) of Panama in 2009 to that in 2010?
Ensure brevity in your answer.  1.01. What is the difference between the highest and the second highest Total Labor Force (in %) in Small states?
Your answer should be very brief. 0.01. What is the difference between the highest and the lowest Total Labor Force (in %) of Small states?
Provide a succinct answer. 0.53. What is the difference between the highest and the lowest Total Labor Force (in %) in Bhutan?
Your answer should be compact. 3. 